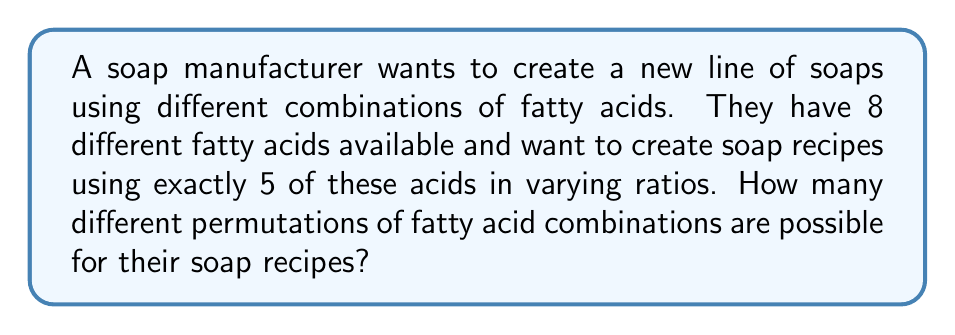Provide a solution to this math problem. Let's approach this step-by-step:

1) First, we need to choose 5 fatty acids from the 8 available. This is a combination problem, represented by $\binom{8}{5}$.

2) The number of combinations is calculated as:

   $$\binom{8}{5} = \frac{8!}{5!(8-5)!} = \frac{8!}{5!3!}$$

3) Expanding this:
   $$\frac{8 \cdot 7 \cdot 6 \cdot 5!}{5! \cdot 3 \cdot 2 \cdot 1} = 56$$

4) Now, for each of these 56 combinations, we need to consider the permutations of the 5 chosen fatty acids, as their order in the recipe can affect the soap's properties.

5) The number of permutations of 5 items is simply 5!, which is:

   $$5! = 5 \cdot 4 \cdot 3 \cdot 2 \cdot 1 = 120$$

6) By the multiplication principle, the total number of permutations is the product of the number of combinations and the number of permutations for each combination:

   $$56 \cdot 120 = 6,720$$

Thus, there are 6,720 different permutations of fatty acid combinations possible for the soap recipes.
Answer: 6,720 permutations 